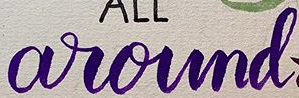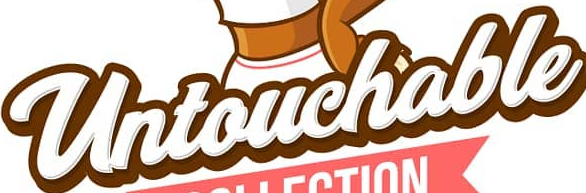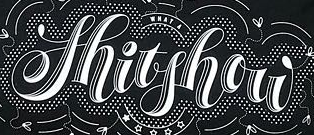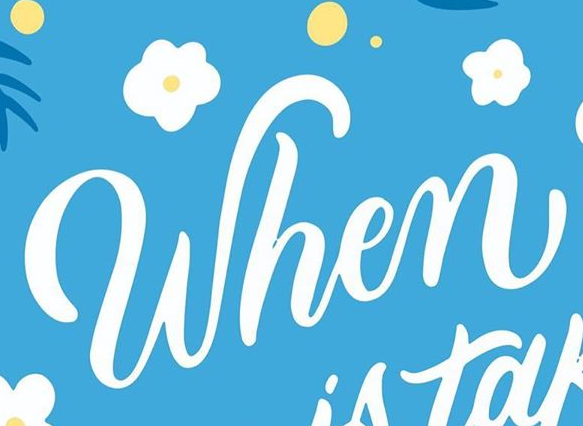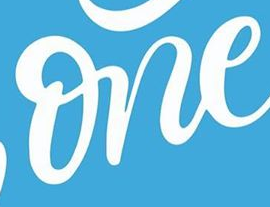Identify the words shown in these images in order, separated by a semicolon. around; Untouchable; Shitshow; When; one 